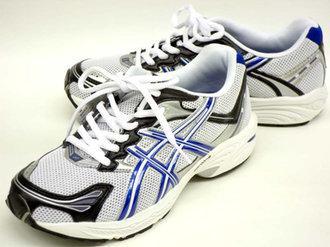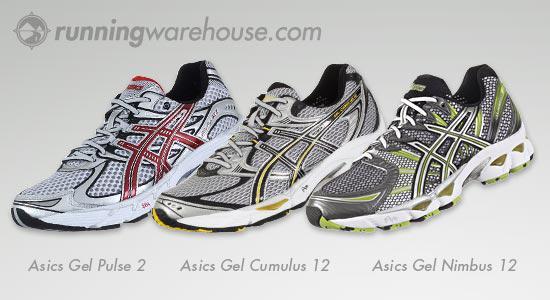The first image is the image on the left, the second image is the image on the right. For the images displayed, is the sentence "There is no more than one tennis shoe in the left image." factually correct? Answer yes or no. No. The first image is the image on the left, the second image is the image on the right. Analyze the images presented: Is the assertion "At least one image shows a pair of shoes that lacks the color red." valid? Answer yes or no. Yes. 